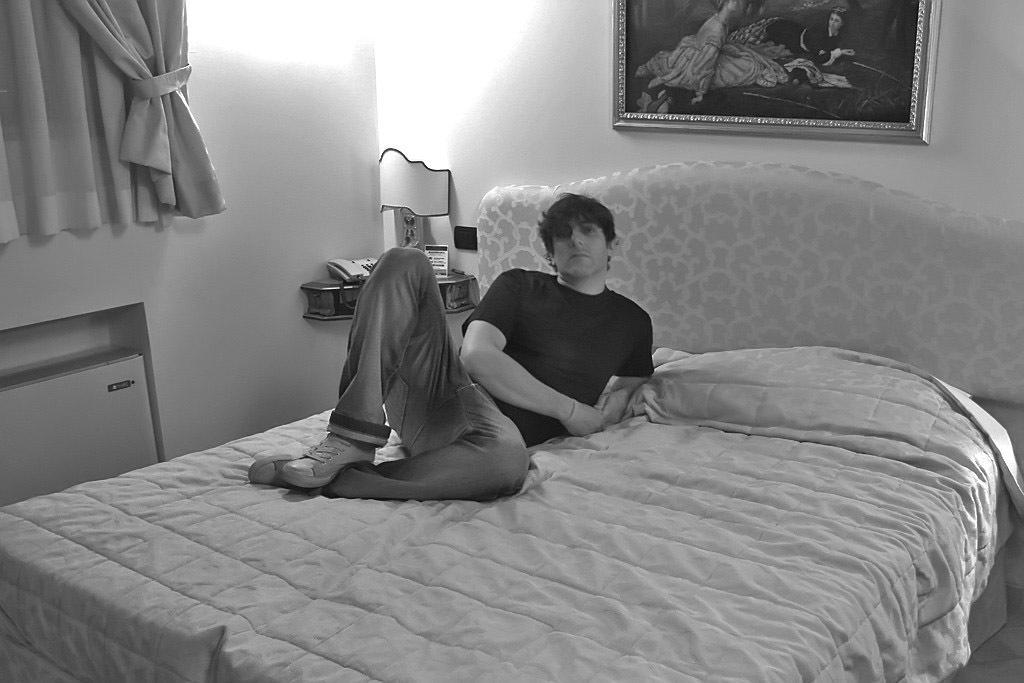How would you summarize this image in a sentence or two? This is a black and white image and here we can see a person lying on the bed and there is a bed sheet. In the background, we can see a curtain and there is a frame on the wall and we can see a light and some other objects on the stand. 